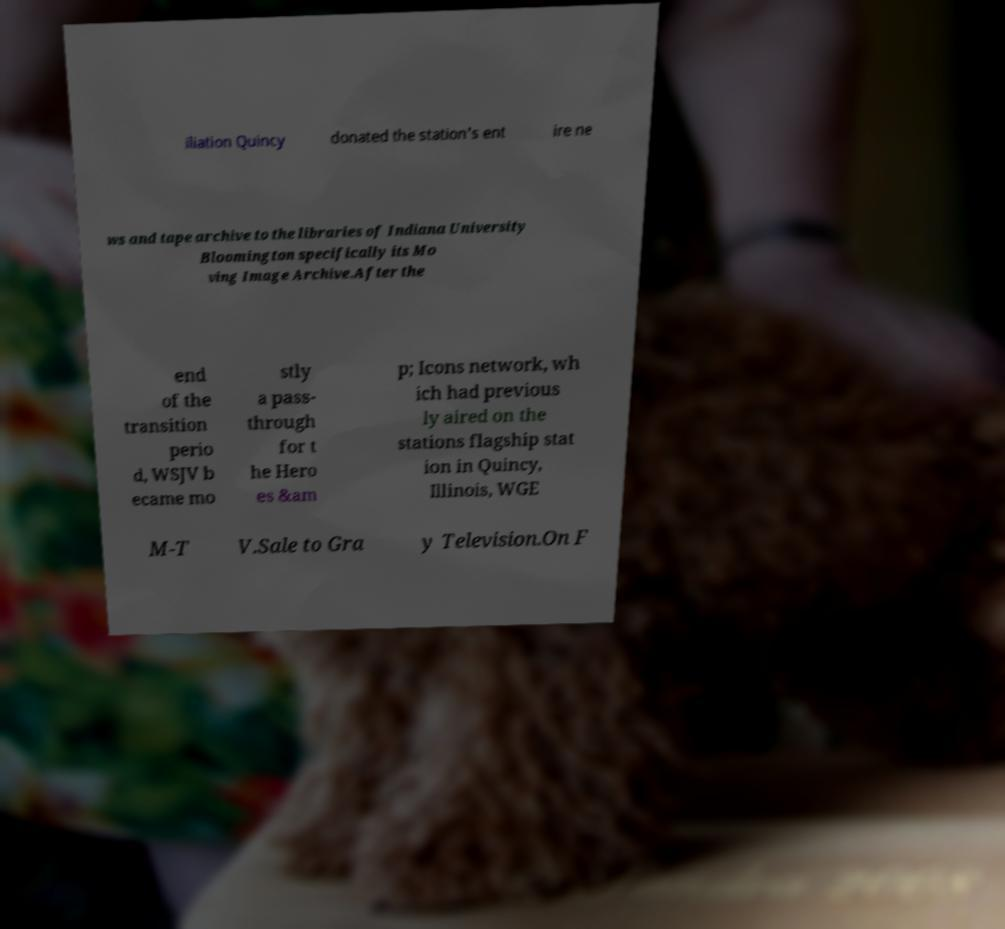Could you assist in decoding the text presented in this image and type it out clearly? iliation Quincy donated the station's ent ire ne ws and tape archive to the libraries of Indiana University Bloomington specifically its Mo ving Image Archive.After the end of the transition perio d, WSJV b ecame mo stly a pass- through for t he Hero es &am p; Icons network, wh ich had previous ly aired on the stations flagship stat ion in Quincy, Illinois, WGE M-T V.Sale to Gra y Television.On F 